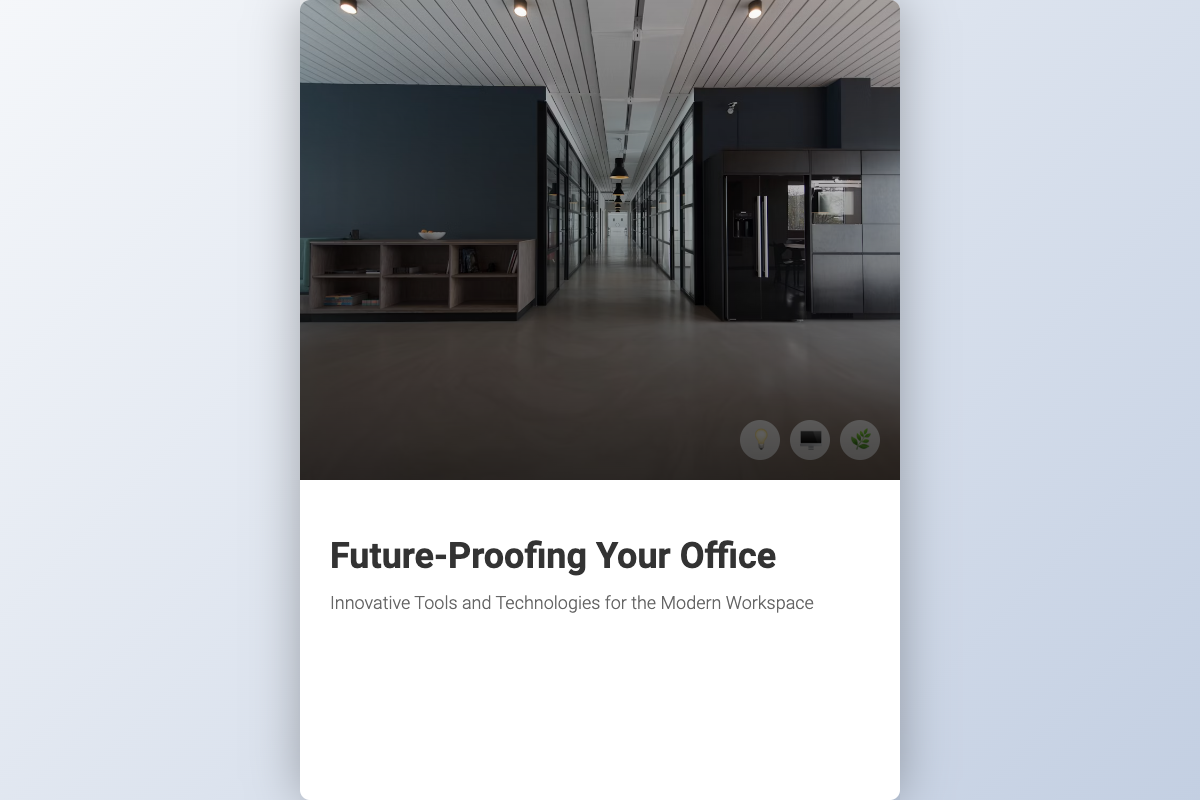what is the title of the book? The title is prominently displayed on the cover and is "Future-Proofing Your Office".
Answer: Future-Proofing Your Office who is the author of the book? The author's name is listed at the bottom of the cover as "John Doe, Tech Startup Product Manager".
Answer: John Doe, Tech Startup Product Manager what is the subtitle of the book? The subtitle is located below the title and reads “Innovative Tools and Technologies for the Modern Workspace”.
Answer: Innovative Tools and Technologies for the Modern Workspace how many tech icons are displayed on the cover? The tech icons are located in the bottom right, and there are three visible icons: a light bulb, a computer, and a plant.
Answer: 3 what design element is featured in the cover image? The cover image showcases futuristic office design elements, including workspace setups that incorporate advanced technology and ergonomic features.
Answer: futuristic office design elements which technology does the icon with the light bulb represent? The light bulb icon typically represents ideas or illumination, suggesting innovation in the workspace setup.
Answer: innovation what color is used for the book cover background? The background of the book cover features a light gradient from light gray to soft blue, creating a modern aesthetic.
Answer: light gradient what is the primary focus of the book according to the subtitle? The subtitle indicates that the book focuses on innovative tools and technologies suited for modern workspaces.
Answer: innovative tools and technologies who is the intended audience of the book? Based on the author's title, the intended audience includes professionals in tech startups and individuals interested in modern office solutions.
Answer: tech startups and professionals 